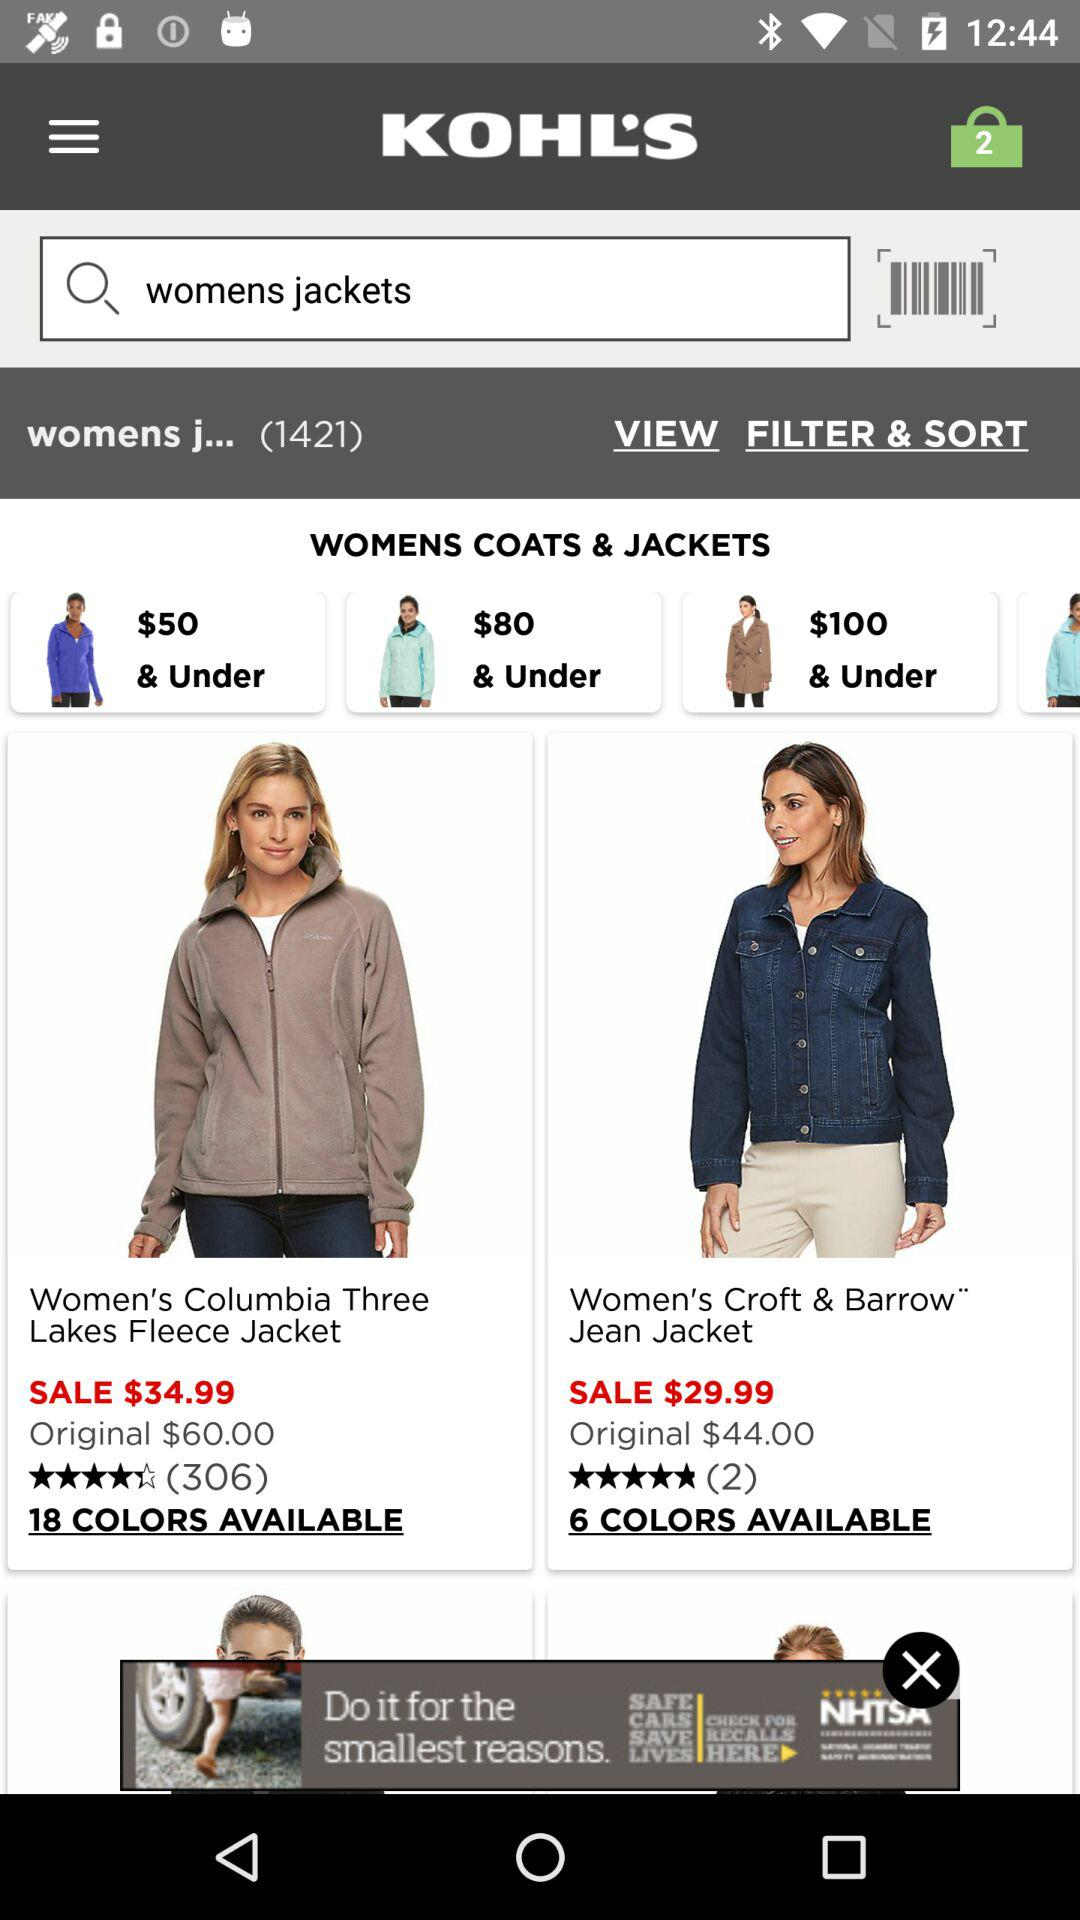How many items are in "womens jackets" filter? There are 1421 items. 